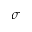<formula> <loc_0><loc_0><loc_500><loc_500>\sigma</formula> 